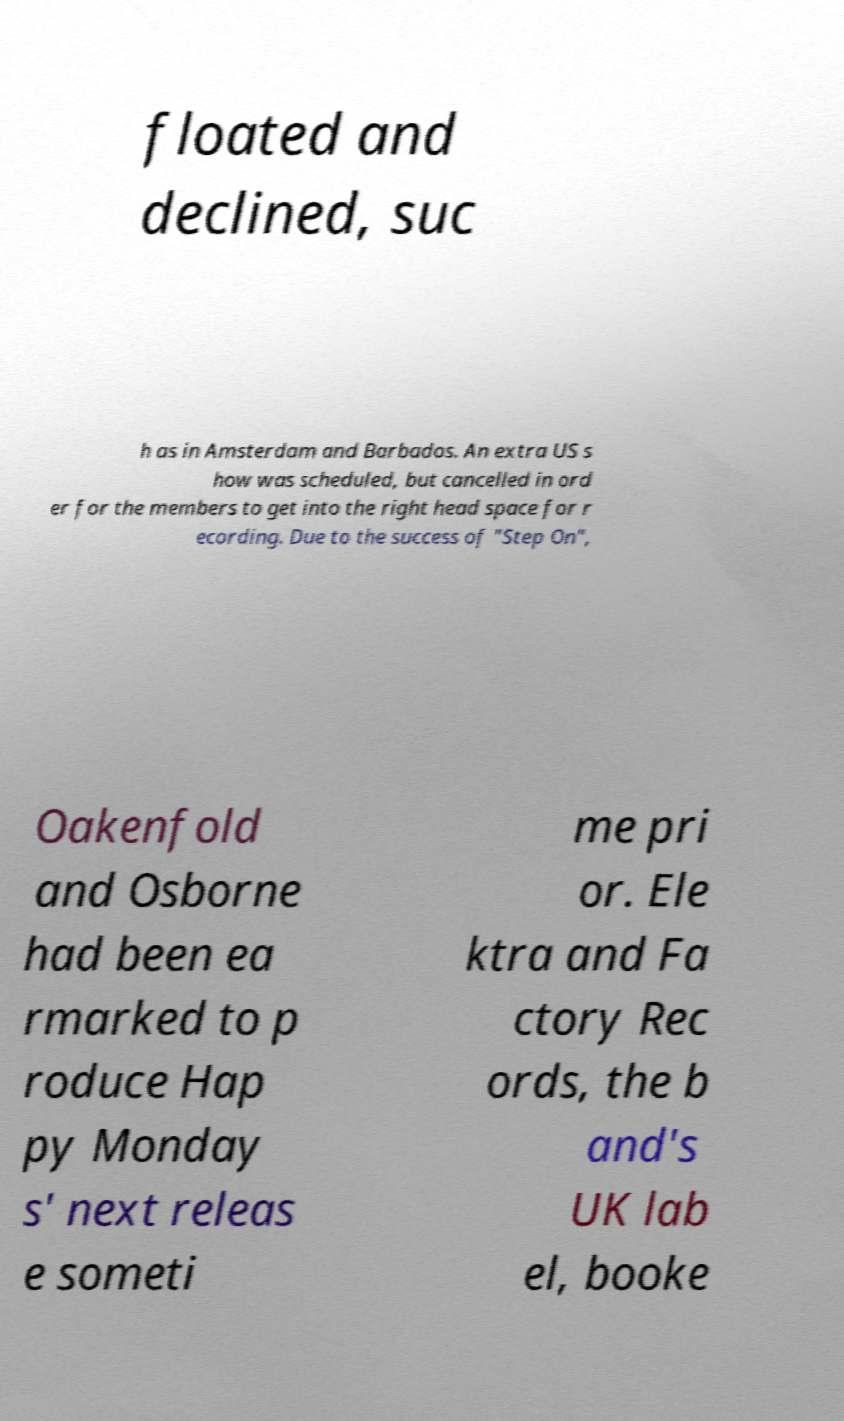Could you extract and type out the text from this image? floated and declined, suc h as in Amsterdam and Barbados. An extra US s how was scheduled, but cancelled in ord er for the members to get into the right head space for r ecording. Due to the success of "Step On", Oakenfold and Osborne had been ea rmarked to p roduce Hap py Monday s' next releas e someti me pri or. Ele ktra and Fa ctory Rec ords, the b and's UK lab el, booke 